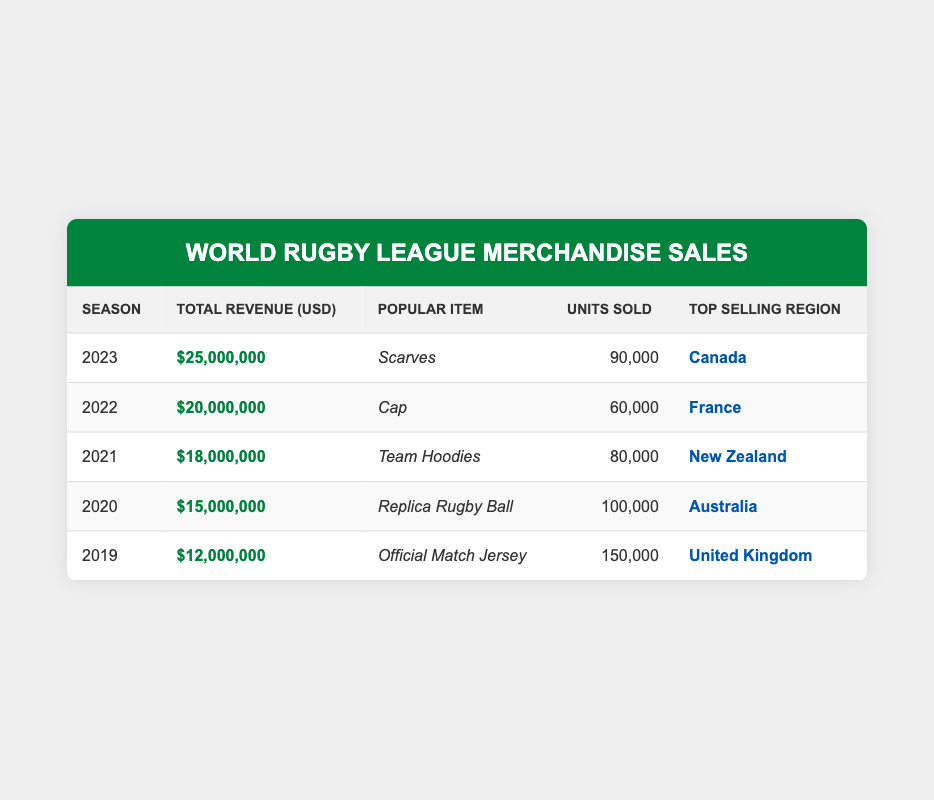What was the top-selling item in the 2021 season? The table lists each season along with the popular item sold that year. For the 2021 season, the popular item is "Team Hoodies."
Answer: Team Hoodies How much revenue was generated from merchandise sales in 2022? To find the revenue for the 2022 season, refer to the Total Revenue column for that year. It shows $20,000,000.
Answer: $20,000,000 Which season had the highest revenue? By comparing the Total Revenue values for each season, 2023 has the highest revenue at $25,000,000.
Answer: 2023 What is the average revenue generated from merchandise sales over the five seasons? The total revenue over five seasons is $12,000,000 + $15,000,000 + $18,000,000 + $20,000,000 + $25,000,000 = $90,000,000. To find the average, divide by 5, resulting in an average of $90,000,000 / 5 = $18,000,000.
Answer: $18,000,000 Which region was the top-selling region in 2019? The Top Selling Region column for the year 2019 indicates that the United Kingdom was the top-selling region.
Answer: United Kingdom Was the replica rugby ball the popular item in any season? Looking through the Popular Item column, the "Replica Rugby Ball" appears for the 2020 season, confirming it was a popular item in that year.
Answer: Yes In which season did the least number of units get sold, and how many? By comparing the Units Sold across all seasons, 2022 had the least units sold, with 60,000 units.
Answer: 2022, 60,000 How much revenue increased from 2019 to 2023? The revenue in 2019 was $12,000,000, and in 2023 it was $25,000,000. The difference is $25,000,000 - $12,000,000 = $13,000,000.
Answer: $13,000,000 Did the units sold increase from 2020 to 2021? Comparing the Units Sold between 2020 (100,000) and 2021 (80,000), the units sold decreased from 2020 to 2021.
Answer: No 